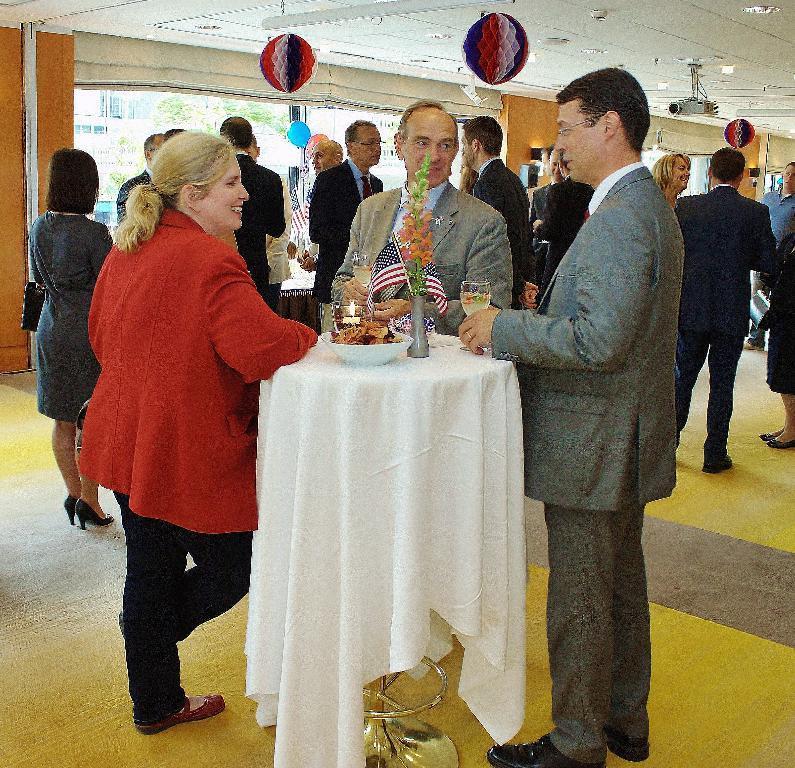Can you describe this image briefly? This picture shows few people standing and we see a table with a flower vase with couple of flags to it and we see a candle and a bowl with some food on the tables and we see couple of men holding glasses in their hands and we see a projector to the roof and couple of balloons and few color papers hanging and we see a woman wore a hand bag. 